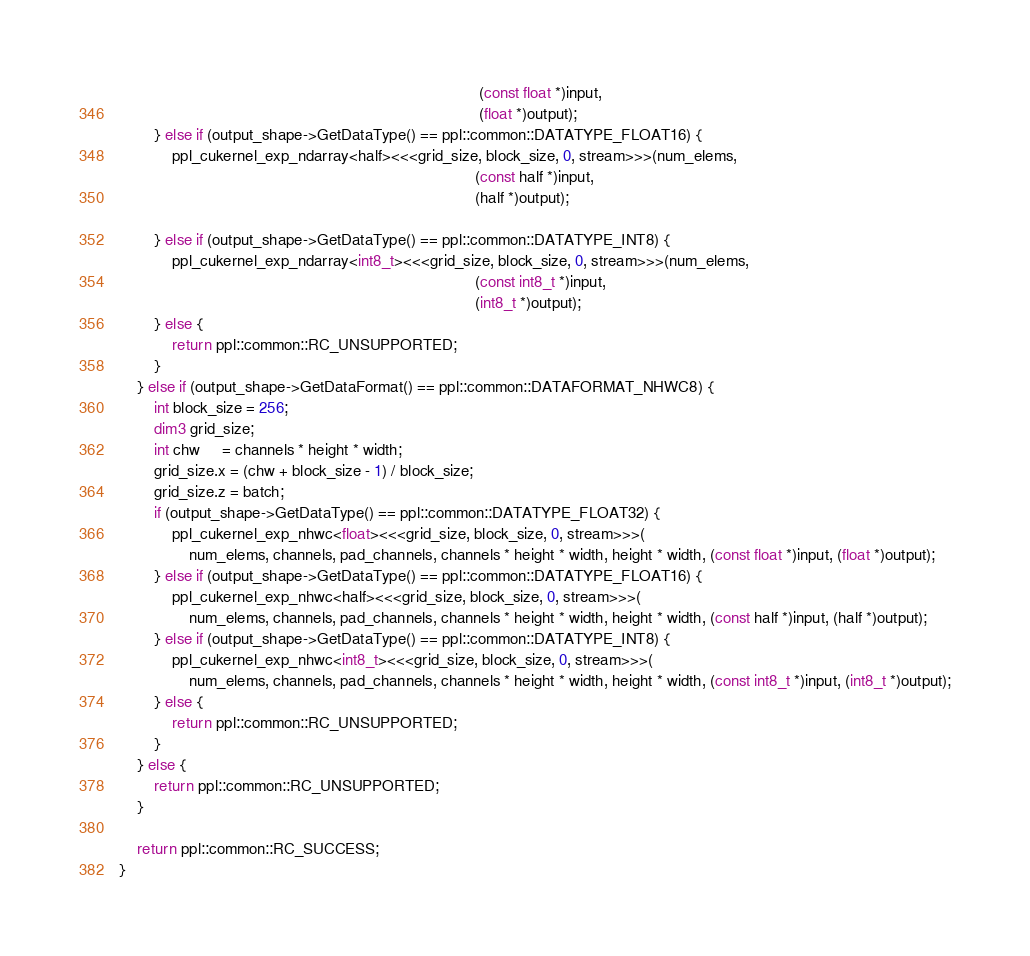<code> <loc_0><loc_0><loc_500><loc_500><_Cuda_>                                                                                  (const float *)input,
                                                                                  (float *)output);
        } else if (output_shape->GetDataType() == ppl::common::DATATYPE_FLOAT16) {
            ppl_cukernel_exp_ndarray<half><<<grid_size, block_size, 0, stream>>>(num_elems,
                                                                                 (const half *)input,
                                                                                 (half *)output);

        } else if (output_shape->GetDataType() == ppl::common::DATATYPE_INT8) {
            ppl_cukernel_exp_ndarray<int8_t><<<grid_size, block_size, 0, stream>>>(num_elems,
                                                                                 (const int8_t *)input,
                                                                                 (int8_t *)output);
        } else {
            return ppl::common::RC_UNSUPPORTED;
        }
    } else if (output_shape->GetDataFormat() == ppl::common::DATAFORMAT_NHWC8) {
        int block_size = 256;
        dim3 grid_size;
        int chw     = channels * height * width;
        grid_size.x = (chw + block_size - 1) / block_size;
        grid_size.z = batch;
        if (output_shape->GetDataType() == ppl::common::DATATYPE_FLOAT32) {
            ppl_cukernel_exp_nhwc<float><<<grid_size, block_size, 0, stream>>>(
                num_elems, channels, pad_channels, channels * height * width, height * width, (const float *)input, (float *)output);
        } else if (output_shape->GetDataType() == ppl::common::DATATYPE_FLOAT16) {
            ppl_cukernel_exp_nhwc<half><<<grid_size, block_size, 0, stream>>>(
                num_elems, channels, pad_channels, channels * height * width, height * width, (const half *)input, (half *)output);
        } else if (output_shape->GetDataType() == ppl::common::DATATYPE_INT8) {
            ppl_cukernel_exp_nhwc<int8_t><<<grid_size, block_size, 0, stream>>>(
                num_elems, channels, pad_channels, channels * height * width, height * width, (const int8_t *)input, (int8_t *)output);
        } else {
            return ppl::common::RC_UNSUPPORTED;
        }
    } else {
        return ppl::common::RC_UNSUPPORTED;
    }

    return ppl::common::RC_SUCCESS;
}</code> 